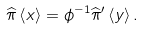Convert formula to latex. <formula><loc_0><loc_0><loc_500><loc_500>\widehat { \pi } \left \langle x \right \rangle = \phi ^ { - 1 } \widehat { \pi } ^ { \prime } \left \langle y \right \rangle .</formula> 